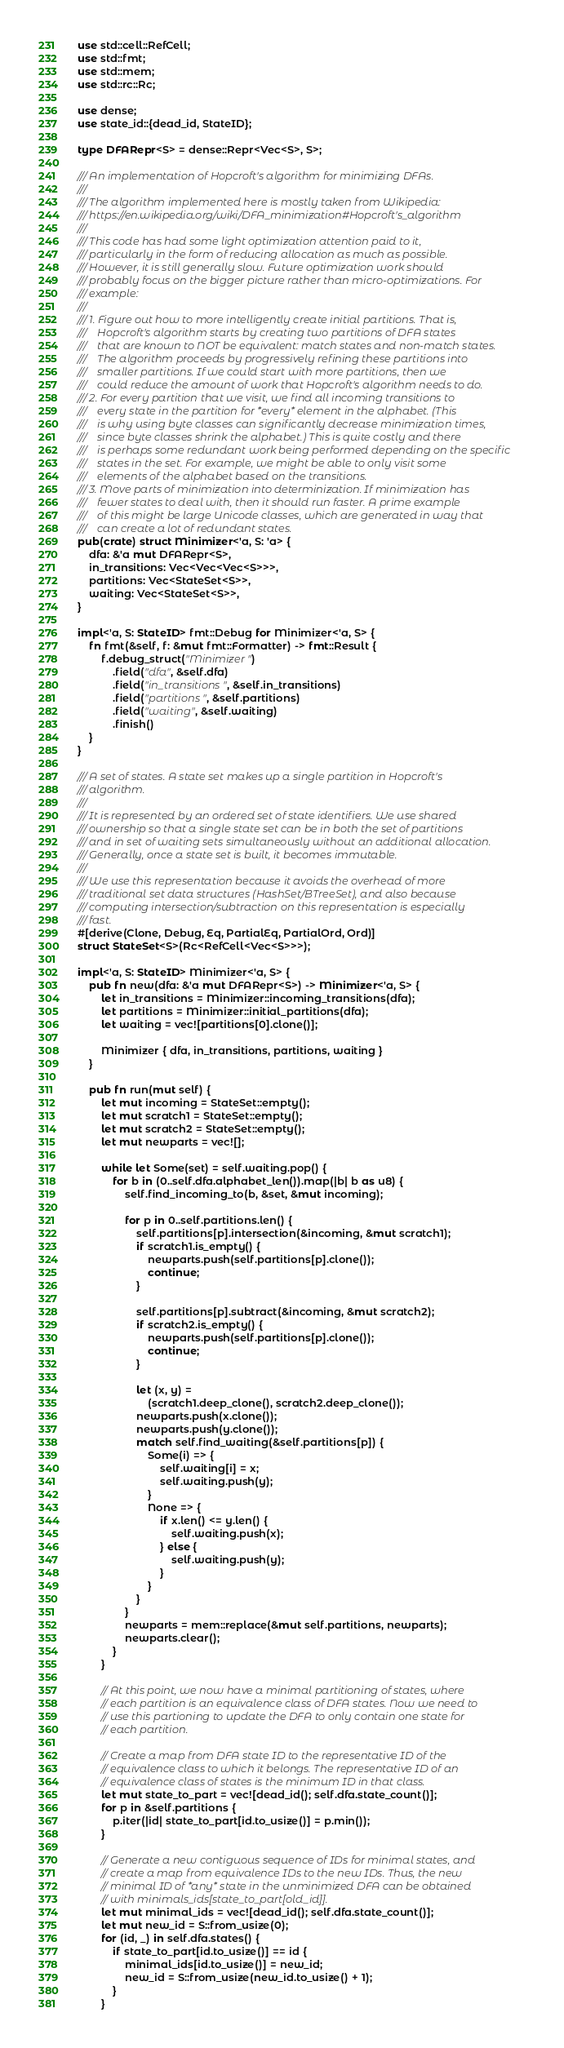Convert code to text. <code><loc_0><loc_0><loc_500><loc_500><_Rust_>use std::cell::RefCell;
use std::fmt;
use std::mem;
use std::rc::Rc;

use dense;
use state_id::{dead_id, StateID};

type DFARepr<S> = dense::Repr<Vec<S>, S>;

/// An implementation of Hopcroft's algorithm for minimizing DFAs.
///
/// The algorithm implemented here is mostly taken from Wikipedia:
/// https://en.wikipedia.org/wiki/DFA_minimization#Hopcroft's_algorithm
///
/// This code has had some light optimization attention paid to it,
/// particularly in the form of reducing allocation as much as possible.
/// However, it is still generally slow. Future optimization work should
/// probably focus on the bigger picture rather than micro-optimizations. For
/// example:
///
/// 1. Figure out how to more intelligently create initial partitions. That is,
///    Hopcroft's algorithm starts by creating two partitions of DFA states
///    that are known to NOT be equivalent: match states and non-match states.
///    The algorithm proceeds by progressively refining these partitions into
///    smaller partitions. If we could start with more partitions, then we
///    could reduce the amount of work that Hopcroft's algorithm needs to do.
/// 2. For every partition that we visit, we find all incoming transitions to
///    every state in the partition for *every* element in the alphabet. (This
///    is why using byte classes can significantly decrease minimization times,
///    since byte classes shrink the alphabet.) This is quite costly and there
///    is perhaps some redundant work being performed depending on the specific
///    states in the set. For example, we might be able to only visit some
///    elements of the alphabet based on the transitions.
/// 3. Move parts of minimization into determinization. If minimization has
///    fewer states to deal with, then it should run faster. A prime example
///    of this might be large Unicode classes, which are generated in way that
///    can create a lot of redundant states.
pub(crate) struct Minimizer<'a, S: 'a> {
    dfa: &'a mut DFARepr<S>,
    in_transitions: Vec<Vec<Vec<S>>>,
    partitions: Vec<StateSet<S>>,
    waiting: Vec<StateSet<S>>,
}

impl<'a, S: StateID> fmt::Debug for Minimizer<'a, S> {
    fn fmt(&self, f: &mut fmt::Formatter) -> fmt::Result {
        f.debug_struct("Minimizer")
            .field("dfa", &self.dfa)
            .field("in_transitions", &self.in_transitions)
            .field("partitions", &self.partitions)
            .field("waiting", &self.waiting)
            .finish()
    }
}

/// A set of states. A state set makes up a single partition in Hopcroft's
/// algorithm.
///
/// It is represented by an ordered set of state identifiers. We use shared
/// ownership so that a single state set can be in both the set of partitions
/// and in set of waiting sets simultaneously without an additional allocation.
/// Generally, once a state set is built, it becomes immutable.
///
/// We use this representation because it avoids the overhead of more
/// traditional set data structures (HashSet/BTreeSet), and also because
/// computing intersection/subtraction on this representation is especially
/// fast.
#[derive(Clone, Debug, Eq, PartialEq, PartialOrd, Ord)]
struct StateSet<S>(Rc<RefCell<Vec<S>>>);

impl<'a, S: StateID> Minimizer<'a, S> {
    pub fn new(dfa: &'a mut DFARepr<S>) -> Minimizer<'a, S> {
        let in_transitions = Minimizer::incoming_transitions(dfa);
        let partitions = Minimizer::initial_partitions(dfa);
        let waiting = vec![partitions[0].clone()];

        Minimizer { dfa, in_transitions, partitions, waiting }
    }

    pub fn run(mut self) {
        let mut incoming = StateSet::empty();
        let mut scratch1 = StateSet::empty();
        let mut scratch2 = StateSet::empty();
        let mut newparts = vec![];

        while let Some(set) = self.waiting.pop() {
            for b in (0..self.dfa.alphabet_len()).map(|b| b as u8) {
                self.find_incoming_to(b, &set, &mut incoming);

                for p in 0..self.partitions.len() {
                    self.partitions[p].intersection(&incoming, &mut scratch1);
                    if scratch1.is_empty() {
                        newparts.push(self.partitions[p].clone());
                        continue;
                    }

                    self.partitions[p].subtract(&incoming, &mut scratch2);
                    if scratch2.is_empty() {
                        newparts.push(self.partitions[p].clone());
                        continue;
                    }

                    let (x, y) =
                        (scratch1.deep_clone(), scratch2.deep_clone());
                    newparts.push(x.clone());
                    newparts.push(y.clone());
                    match self.find_waiting(&self.partitions[p]) {
                        Some(i) => {
                            self.waiting[i] = x;
                            self.waiting.push(y);
                        }
                        None => {
                            if x.len() <= y.len() {
                                self.waiting.push(x);
                            } else {
                                self.waiting.push(y);
                            }
                        }
                    }
                }
                newparts = mem::replace(&mut self.partitions, newparts);
                newparts.clear();
            }
        }

        // At this point, we now have a minimal partitioning of states, where
        // each partition is an equivalence class of DFA states. Now we need to
        // use this partioning to update the DFA to only contain one state for
        // each partition.

        // Create a map from DFA state ID to the representative ID of the
        // equivalence class to which it belongs. The representative ID of an
        // equivalence class of states is the minimum ID in that class.
        let mut state_to_part = vec![dead_id(); self.dfa.state_count()];
        for p in &self.partitions {
            p.iter(|id| state_to_part[id.to_usize()] = p.min());
        }

        // Generate a new contiguous sequence of IDs for minimal states, and
        // create a map from equivalence IDs to the new IDs. Thus, the new
        // minimal ID of *any* state in the unminimized DFA can be obtained
        // with minimals_ids[state_to_part[old_id]].
        let mut minimal_ids = vec![dead_id(); self.dfa.state_count()];
        let mut new_id = S::from_usize(0);
        for (id, _) in self.dfa.states() {
            if state_to_part[id.to_usize()] == id {
                minimal_ids[id.to_usize()] = new_id;
                new_id = S::from_usize(new_id.to_usize() + 1);
            }
        }</code> 